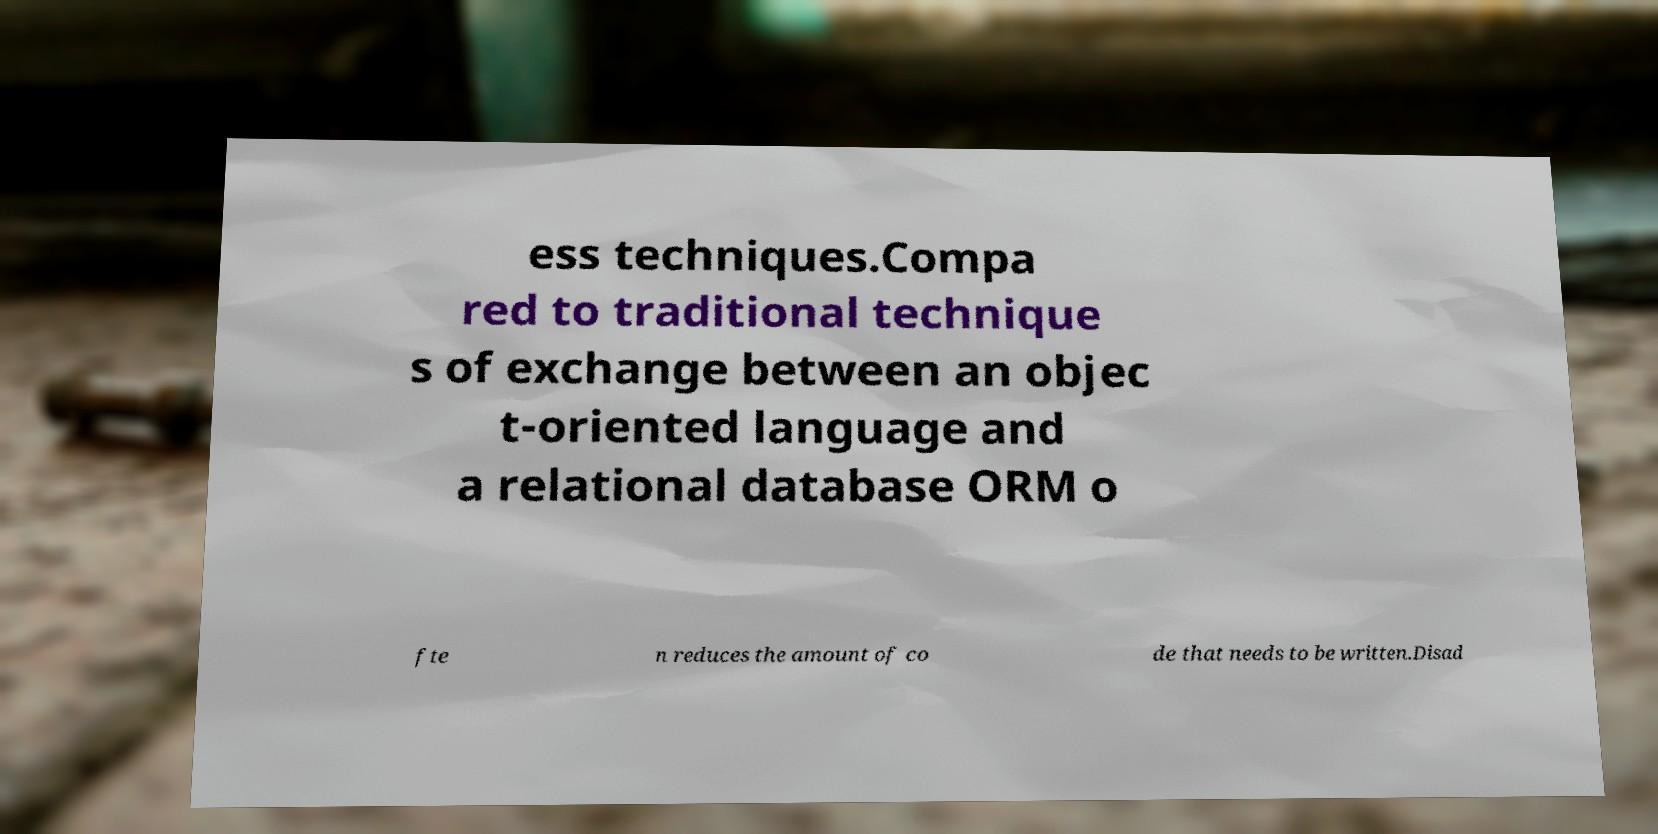Could you assist in decoding the text presented in this image and type it out clearly? ess techniques.Compa red to traditional technique s of exchange between an objec t-oriented language and a relational database ORM o fte n reduces the amount of co de that needs to be written.Disad 